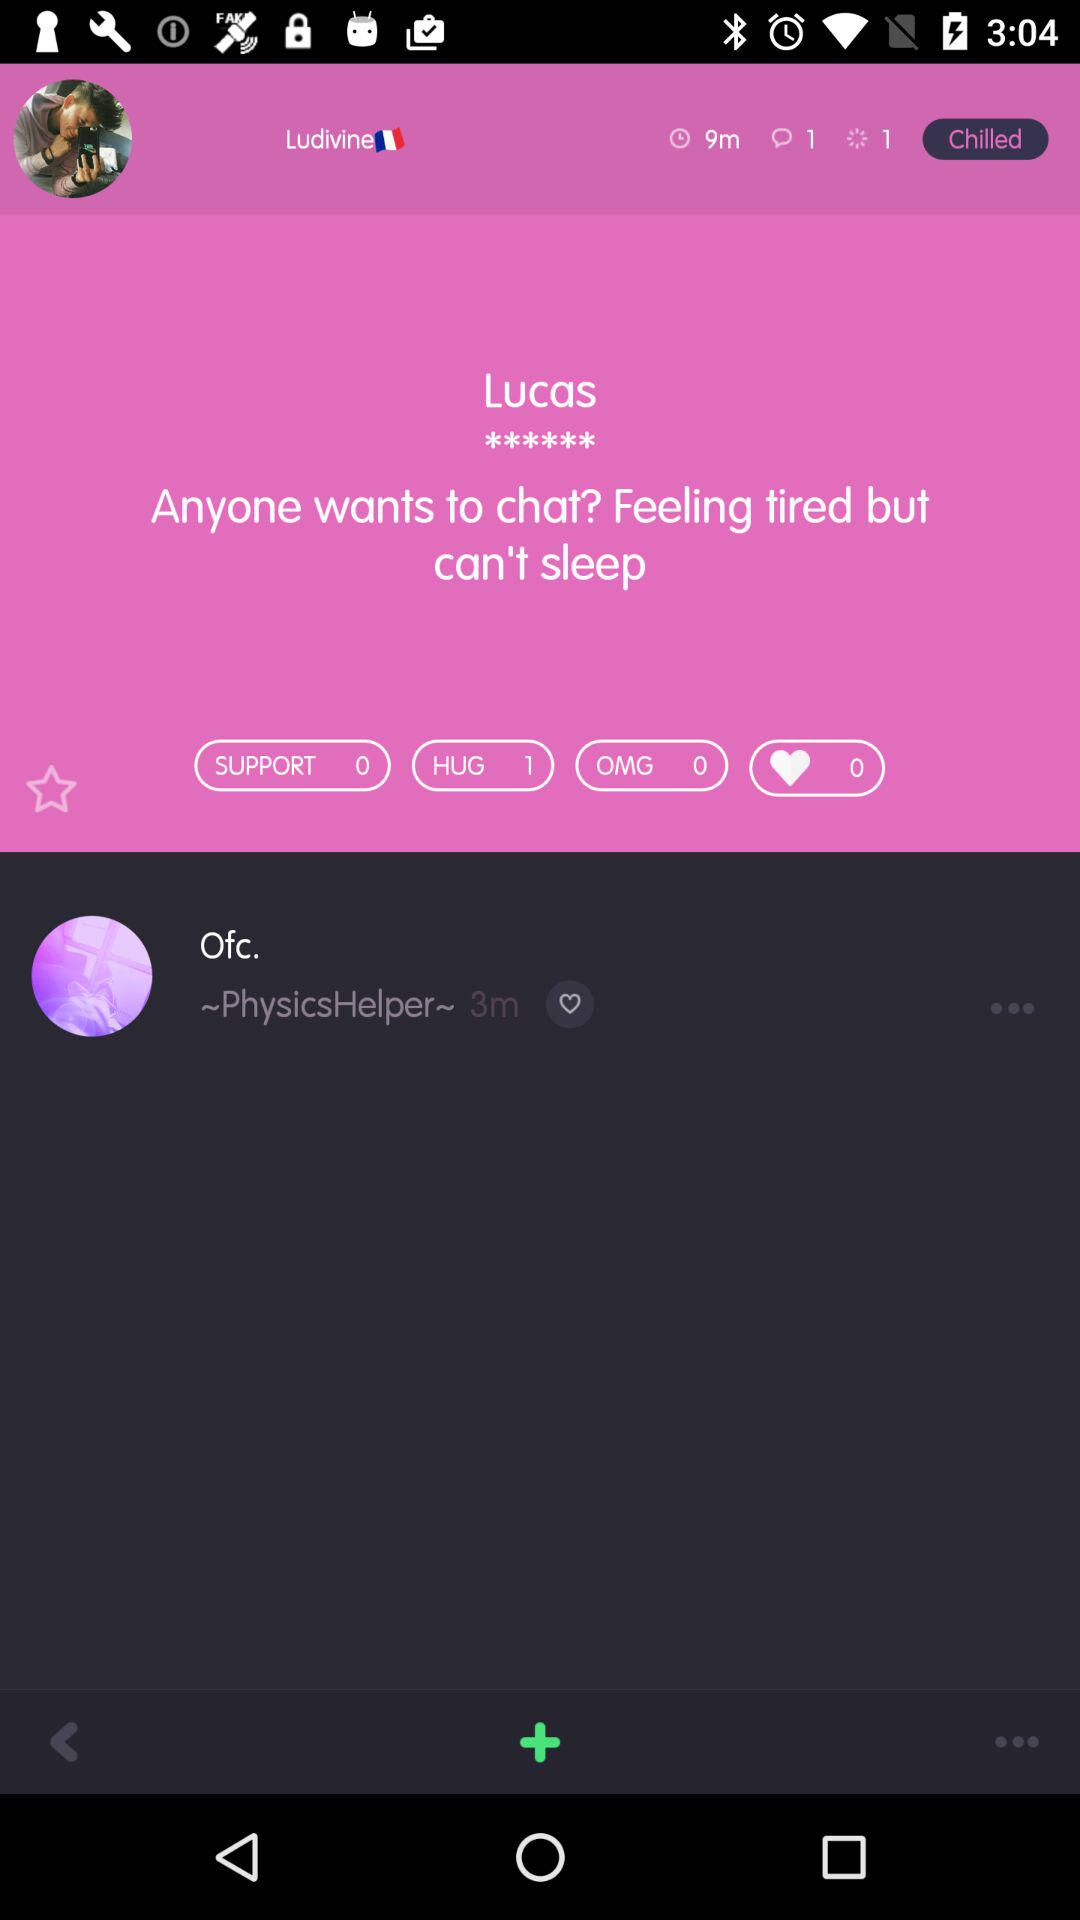How much support has Lucas got? Lucas got 0 support. 